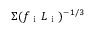<formula> <loc_0><loc_0><loc_500><loc_500>\Sigma ( f _ { i } L _ { i } ) ^ { - 1 / 3 }</formula> 